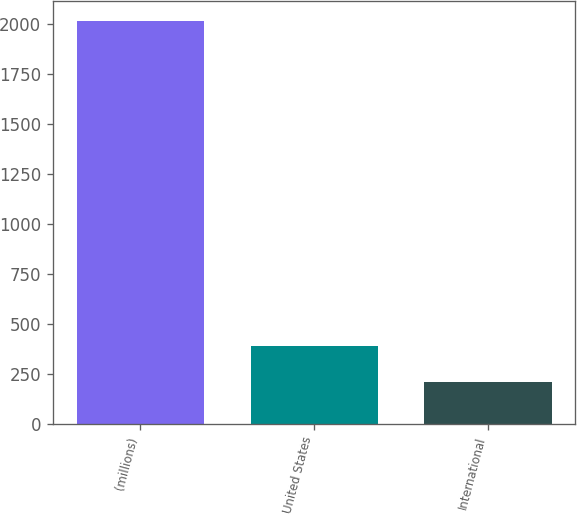Convert chart. <chart><loc_0><loc_0><loc_500><loc_500><bar_chart><fcel>(millions)<fcel>United States<fcel>International<nl><fcel>2016<fcel>386.91<fcel>205.9<nl></chart> 